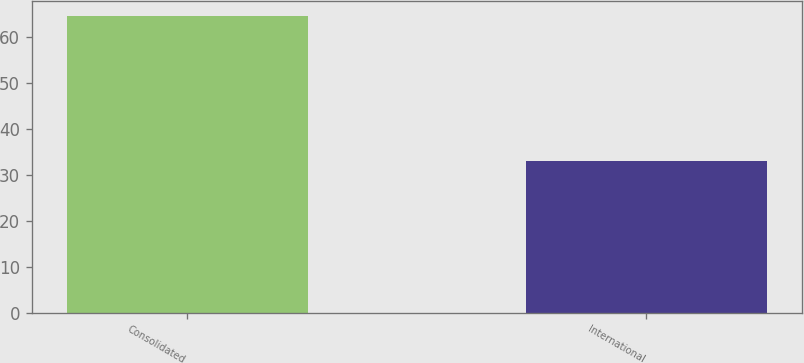Convert chart to OTSL. <chart><loc_0><loc_0><loc_500><loc_500><bar_chart><fcel>Consolidated<fcel>International<nl><fcel>64.6<fcel>32.9<nl></chart> 